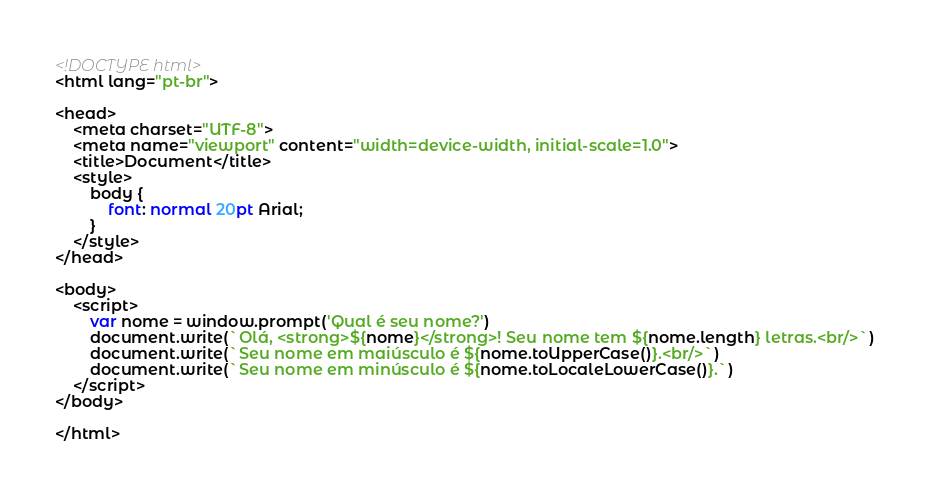Convert code to text. <code><loc_0><loc_0><loc_500><loc_500><_HTML_><!DOCTYPE html>
<html lang="pt-br">

<head>
    <meta charset="UTF-8">
    <meta name="viewport" content="width=device-width, initial-scale=1.0">
    <title>Document</title>
    <style>
        body {
            font: normal 20pt Arial;
        }
    </style>
</head>

<body>
    <script>
        var nome = window.prompt('Qual é seu nome?')
        document.write(`Olá, <strong>${nome}</strong>! Seu nome tem ${nome.length} letras.<br/>`)
        document.write(`Seu nome em maiúsculo é ${nome.toUpperCase()}.<br/>`)
        document.write(`Seu nome em minúsculo é ${nome.toLocaleLowerCase()}.`)
    </script>
</body>

</html></code> 